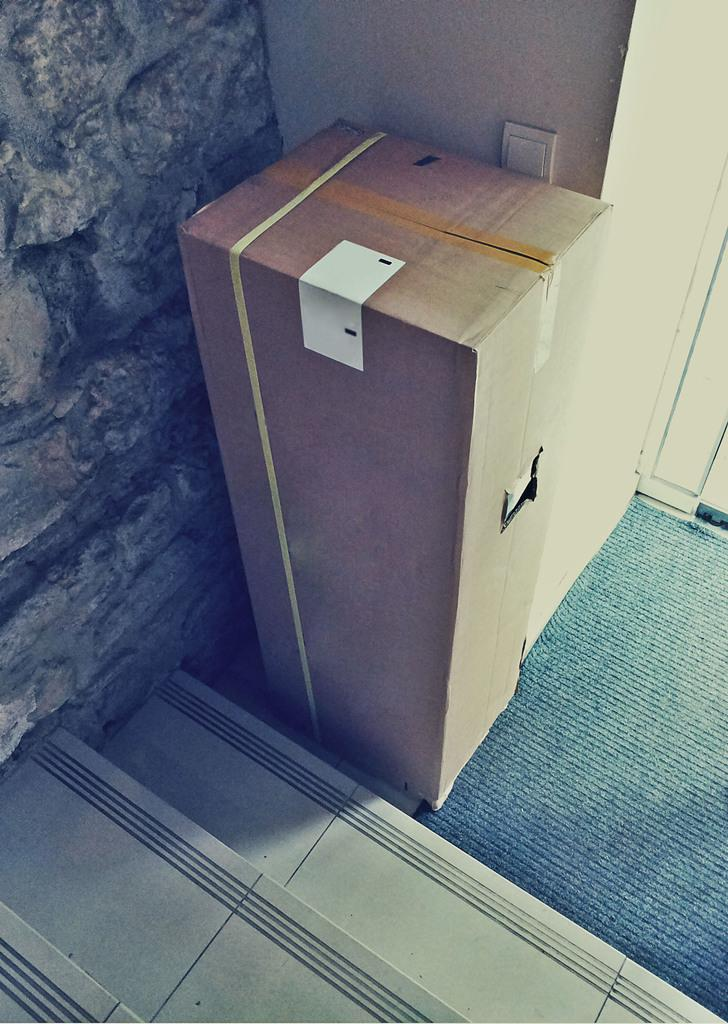What is placed on the green carpet in the image? There is a wooden box on a green carpet. What can be seen on the wall in the image? There is a switch on the wall. What architectural feature is visible in the image? There are stairs visible in the image. What type of wall is on the left side of the image? There is a stone wall on the left side of the image. Can you see a robin perched on the wooden box in the image? There is no robin present in the image. How does the person in the image join the switch to the wooden box? The image does not show a person or any indication of joining the switch to the wooden box. 